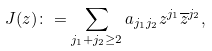Convert formula to latex. <formula><loc_0><loc_0><loc_500><loc_500>J ( z ) \colon = \sum _ { j _ { 1 } + j _ { 2 } \geq 2 } a _ { j _ { 1 } j _ { 2 } } z ^ { j _ { 1 } } \overline { z } ^ { j _ { 2 } } ,</formula> 